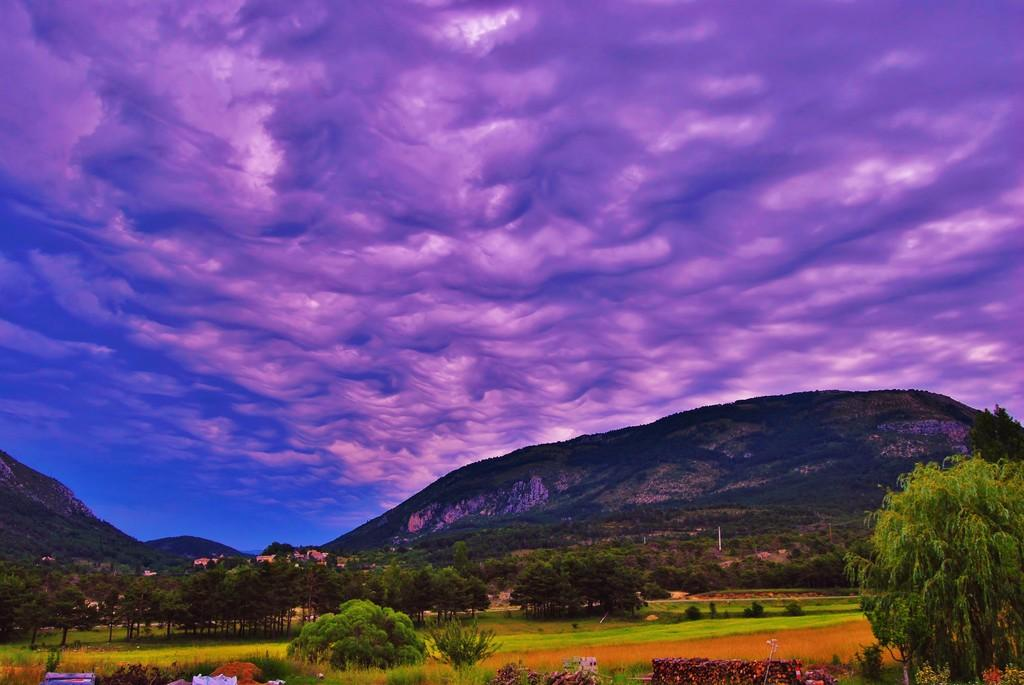What type of natural environment is depicted in the image? There are many trees in the image, indicating a forest or wooded area. What can be seen in the distance in the image? There are mountains in the background of the image. What else is visible in the background of the image? There are clouds in the background of the image. What is visible in the sky in the image? The sky is visible in the image, and it has blue and purple colors. What type of food is the cook preparing in the image? There is no cook or food preparation visible in the image; it depicts a natural landscape. 